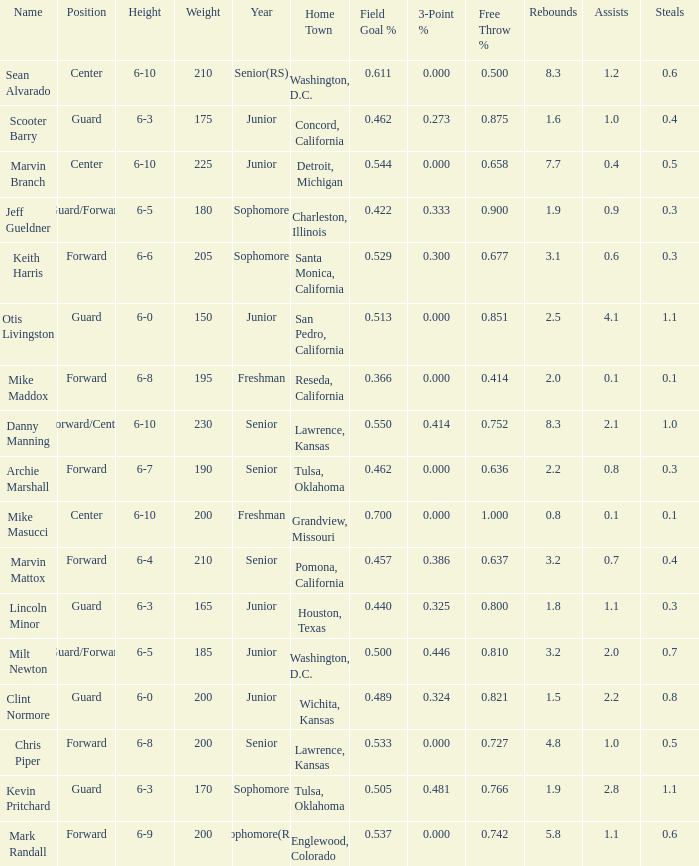Can you tell me the Name that has the Height of 6-5, and the Year of junior? Milt Newton. 